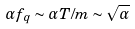Convert formula to latex. <formula><loc_0><loc_0><loc_500><loc_500>\alpha f _ { q } \sim \alpha T / m \sim { \sqrt { \alpha } }</formula> 